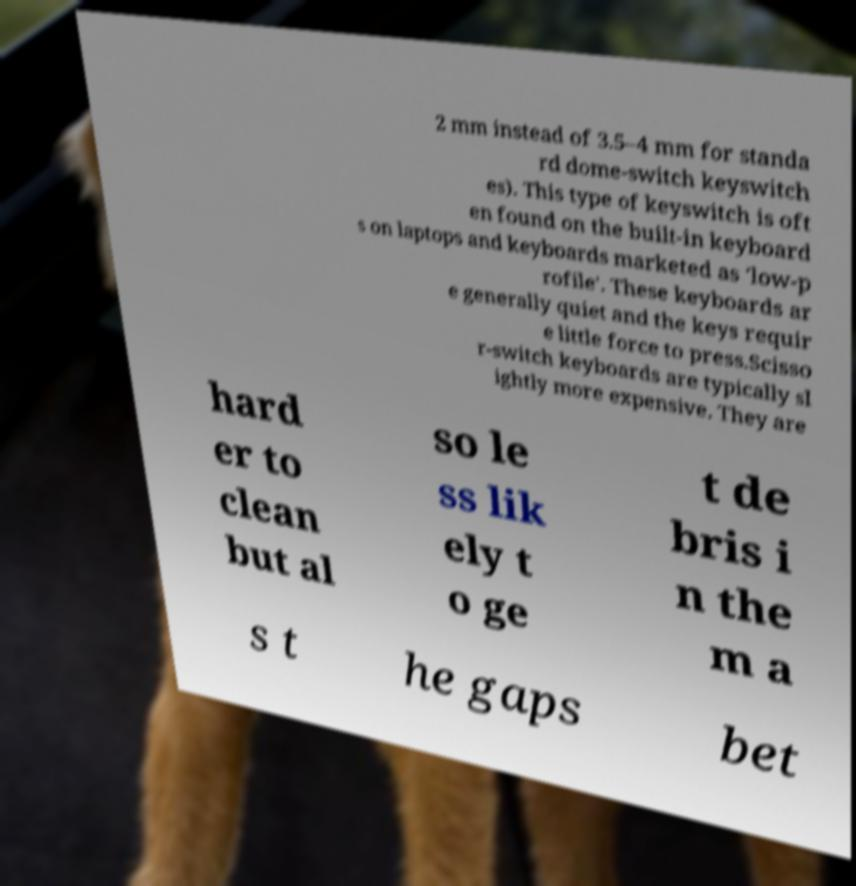What messages or text are displayed in this image? I need them in a readable, typed format. 2 mm instead of 3.5–4 mm for standa rd dome-switch keyswitch es). This type of keyswitch is oft en found on the built-in keyboard s on laptops and keyboards marketed as 'low-p rofile'. These keyboards ar e generally quiet and the keys requir e little force to press.Scisso r-switch keyboards are typically sl ightly more expensive. They are hard er to clean but al so le ss lik ely t o ge t de bris i n the m a s t he gaps bet 